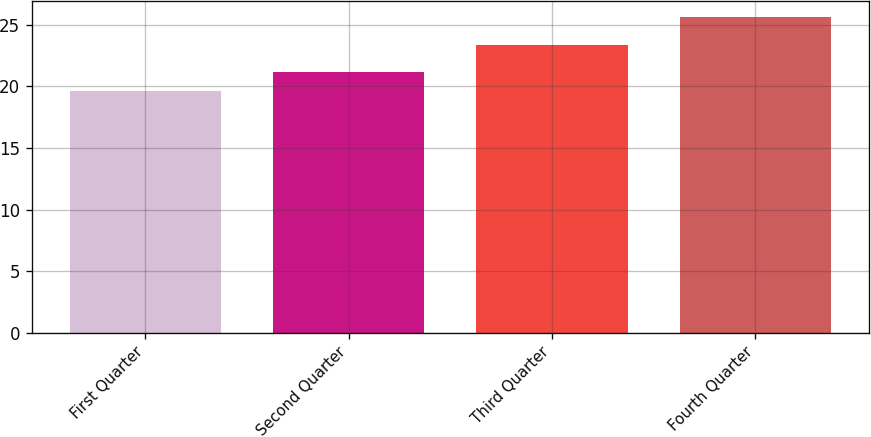<chart> <loc_0><loc_0><loc_500><loc_500><bar_chart><fcel>First Quarter<fcel>Second Quarter<fcel>Third Quarter<fcel>Fourth Quarter<nl><fcel>19.66<fcel>21.18<fcel>23.35<fcel>25.63<nl></chart> 